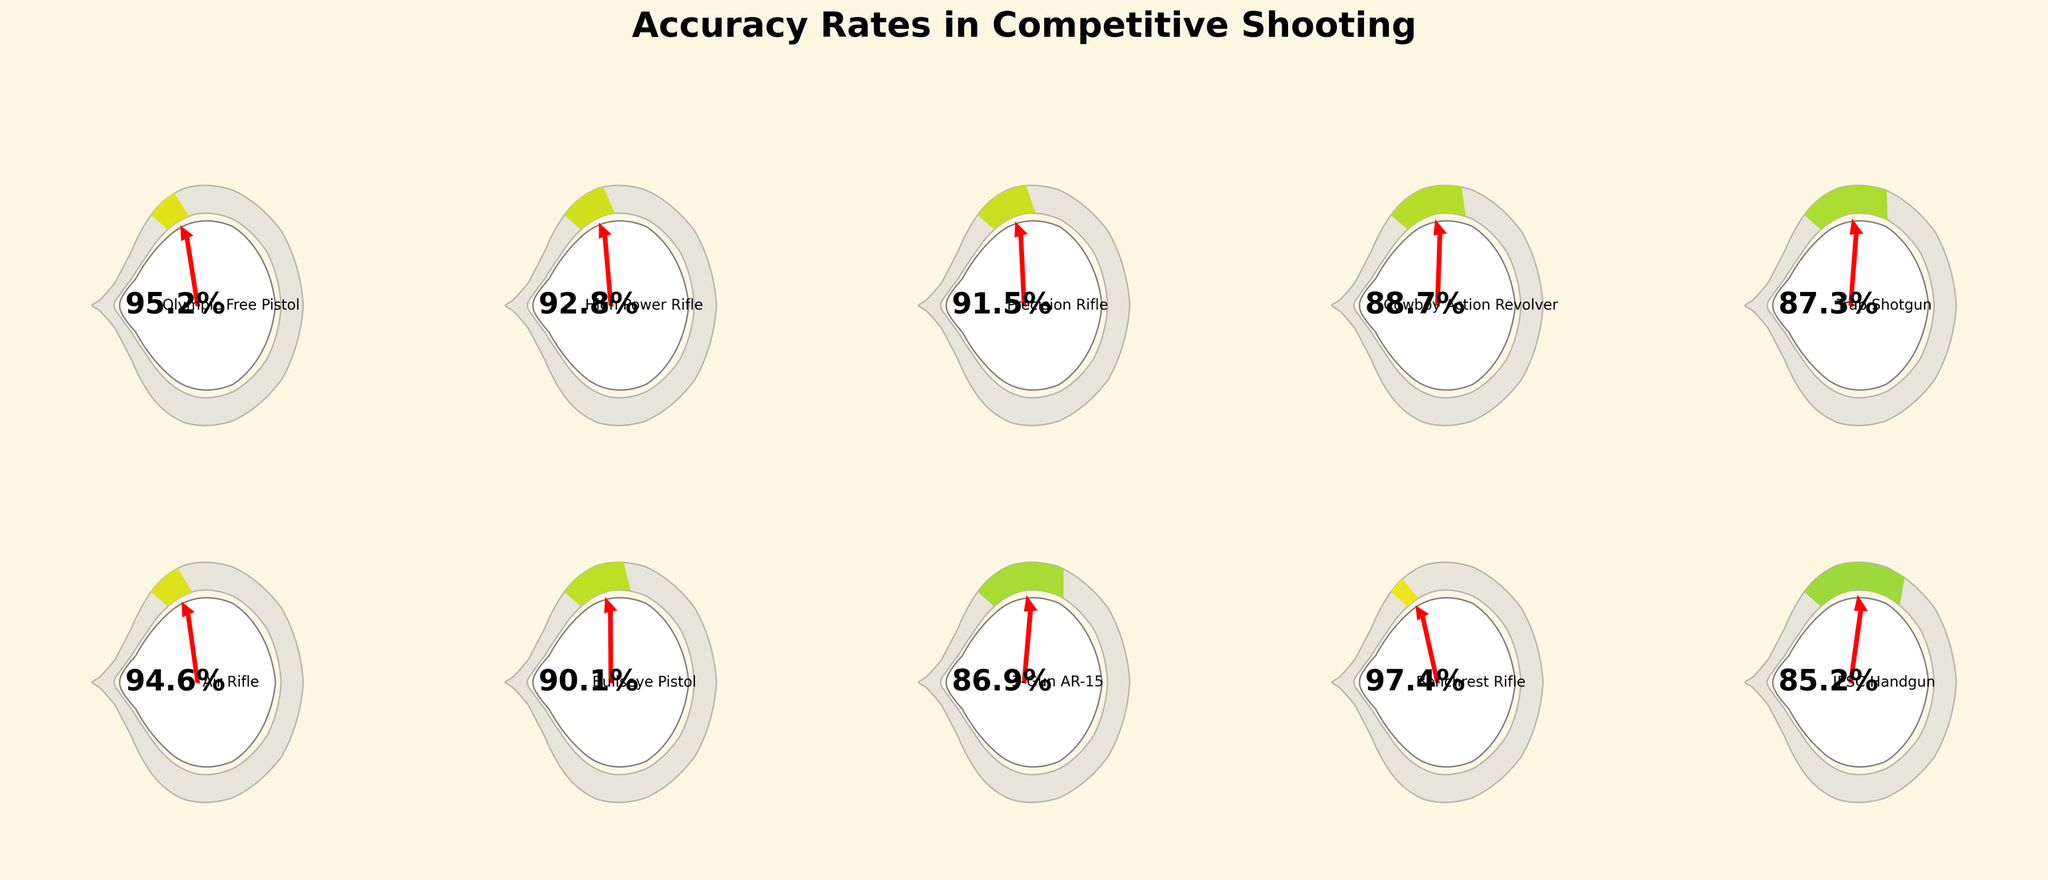What is the title of the figure? The title of the figure is placed at the top center in a larger, bold font, which is standard for identifying the main topic of the visual data representation. The specific title here is "Accuracy Rates in Competitive Shooting."
Answer: Accuracy Rates in Competitive Shooting Which firearm type has the highest accuracy rate? To determine the firearm with the highest accuracy rate, you need to compare the percentage values and identify the maximum one. From the gauge charts, Benchrest Rifle has the highest accuracy at 97.4%.
Answer: Benchrest Rifle What's the accuracy rate of the IPSC Handgun? Look at the specific gauge for the IPSC Handgun and find the accuracy percentage displayed inside the gauge chart. The accuracy rate for IPSC Handgun is 85.2%.
Answer: 85.2% How many firearm types have an accuracy rate above 90%? To find this, count all the gauge charts that show an accuracy rate greater than 90%. There are five firearm types: Olympic Free Pistol (95.2%), High Power Rifle (92.8%), Precision Rifle (91.5%), Air Rifle (94.6%), and Benchrest Rifle (97.4%).
Answer: 5 Which firearm has a lower accuracy rate: Bullseye Pistol or 3-Gun AR-15? Compare the accuracy rates of Bullseye Pistol (90.1%) and 3-Gun AR-15 (86.9%) as seen on their respective gauge charts. The 3-Gun AR-15 has a lower accuracy rate.
Answer: 3-Gun AR-15 What is the average accuracy rate of all the firearms? To calculate the average accuracy rate, sum up all the accuracy rates and divide by the number of firearm types. The rates are: 95.2, 92.8, 91.5, 88.7, 87.3, 94.6, 90.1, 86.9, 97.4, and 85.2. The total is 909.7, and the number of types is 10. So, 909.7 / 10 = 90.97%.
Answer: 90.97% Which firearm type has the most visually prominent red pointer on the gauge chart? The visually prominent red pointer indicates the higher accuracy rates in the gauge charts. By comparing, Benchrest Rifle (97.4%) seems to have the most prominent pointer because it reaches closest to the maximum 100% mark.
Answer: Benchrest Rifle What is the difference in accuracy rate between Trap Shotgun and Cowboy Action Revolver? To find this, subtract the accuracy rate of Trap Shotgun (87.3%) from Cowboy Action Revolver (88.7%). The difference is 88.7% - 87.3% = 1.4%.
Answer: 1.4% What common visual feature indicates accuracy rates across all gauge charts? Each gauge chart features a colored arc that represents the accuracy rate, a numeric percentage displayed within the center, and a red pointer indicating the specific rate visually by its angle. These features help interpret and compare accuracy rates easily.
Answer: Colored arc, numeric percentage, red pointer How does the accuracy rate of the High Power Rifle compare to the Air Rifle? Compare the gauge charts of both the High Power Rifle and the Air Rifle. High Power Rifle has an accuracy of 92.8%, while Air Rifle has 94.6%. Therefore, the Air Rifle has a higher accuracy rate.
Answer: Air Rifle 